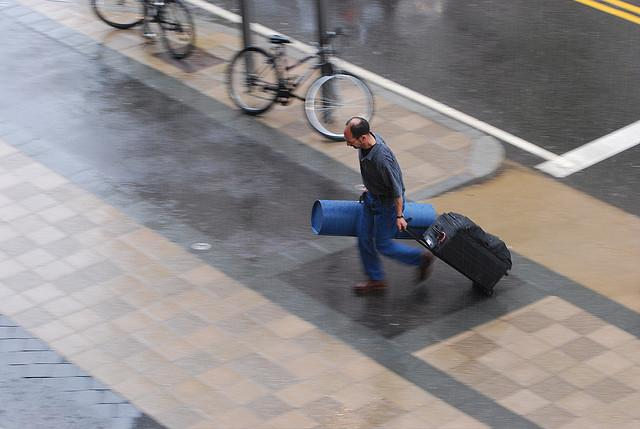What is the man transporting?

Choices:
A) luggage
B) pizza
C) bananas
D) eggs luggage 